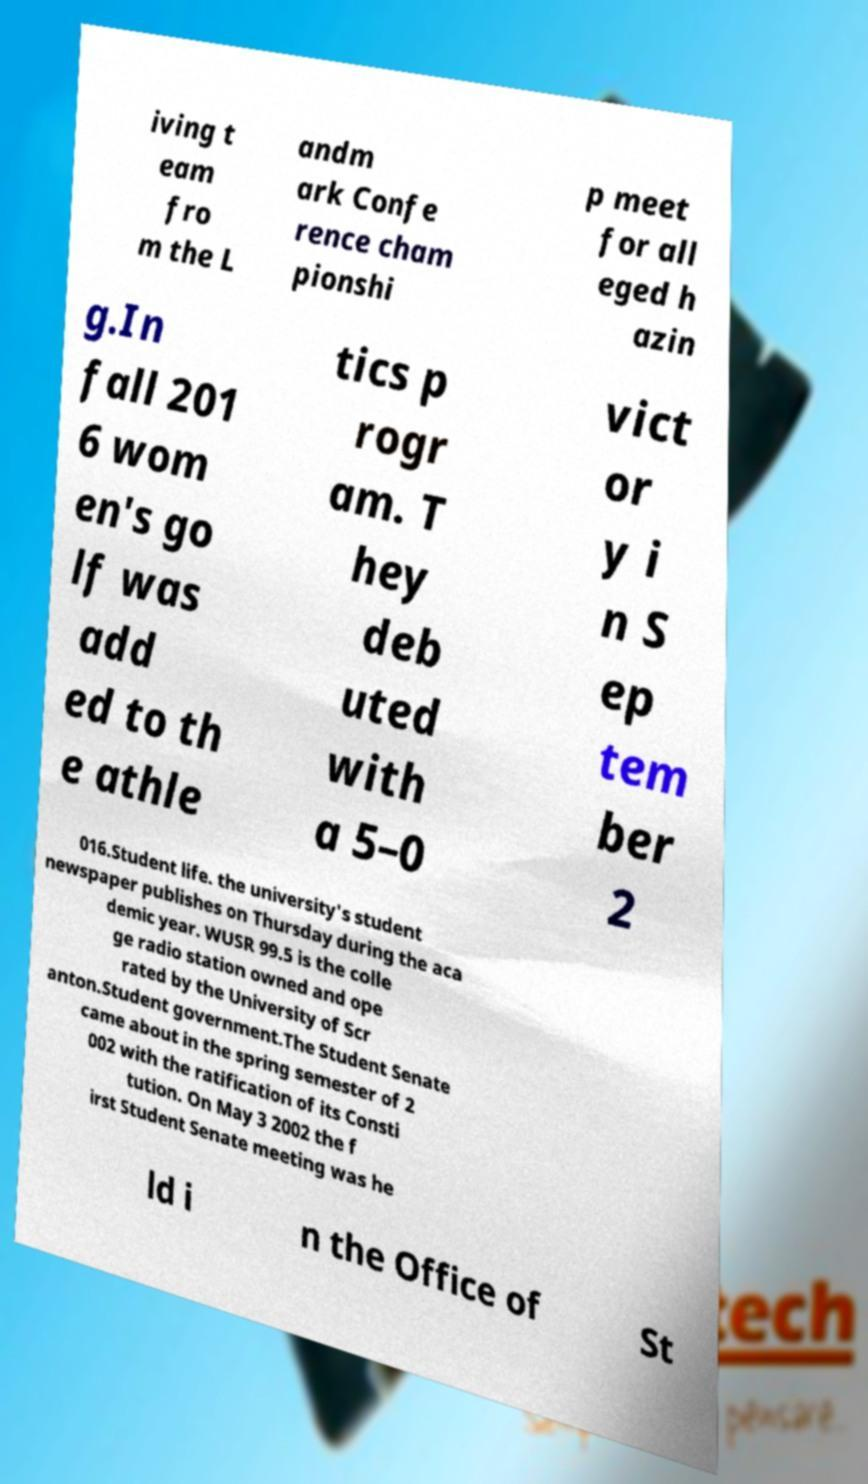There's text embedded in this image that I need extracted. Can you transcribe it verbatim? iving t eam fro m the L andm ark Confe rence cham pionshi p meet for all eged h azin g.In fall 201 6 wom en's go lf was add ed to th e athle tics p rogr am. T hey deb uted with a 5–0 vict or y i n S ep tem ber 2 016.Student life. the university's student newspaper publishes on Thursday during the aca demic year. WUSR 99.5 is the colle ge radio station owned and ope rated by the University of Scr anton.Student government.The Student Senate came about in the spring semester of 2 002 with the ratification of its Consti tution. On May 3 2002 the f irst Student Senate meeting was he ld i n the Office of St 